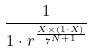Convert formula to latex. <formula><loc_0><loc_0><loc_500><loc_500>\frac { 1 } { 1 \cdot r ^ { \frac { X \times ( 1 \cdot X ) } { 7 ^ { N + 1 } } } }</formula> 